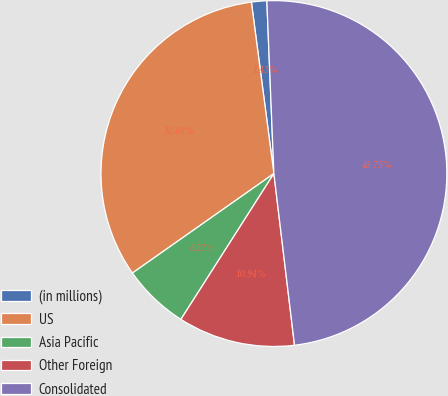Convert chart. <chart><loc_0><loc_0><loc_500><loc_500><pie_chart><fcel>(in millions)<fcel>US<fcel>Asia Pacific<fcel>Other Foreign<fcel>Consolidated<nl><fcel>1.43%<fcel>32.68%<fcel>6.21%<fcel>10.94%<fcel>48.75%<nl></chart> 